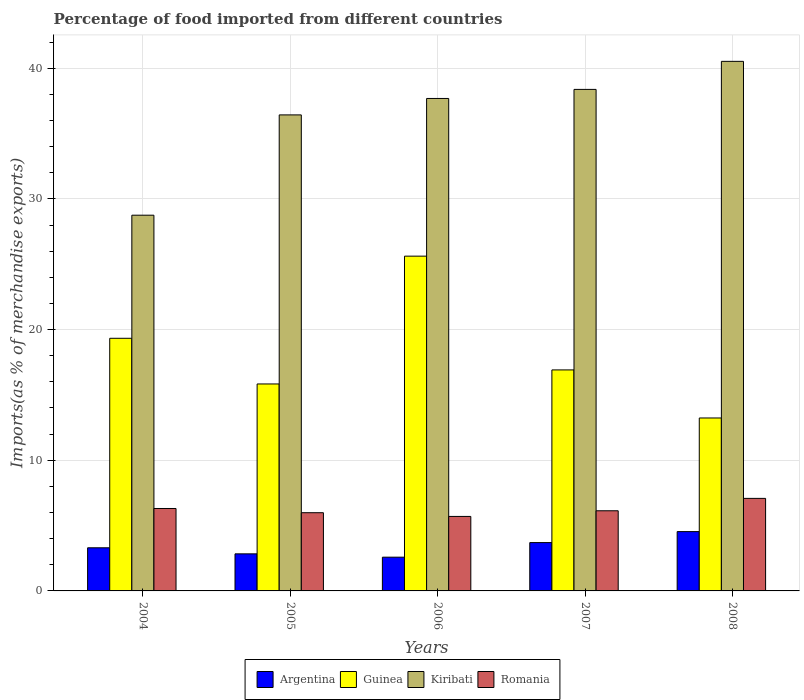How many bars are there on the 4th tick from the left?
Give a very brief answer. 4. How many bars are there on the 5th tick from the right?
Your answer should be very brief. 4. In how many cases, is the number of bars for a given year not equal to the number of legend labels?
Provide a succinct answer. 0. What is the percentage of imports to different countries in Romania in 2006?
Your response must be concise. 5.7. Across all years, what is the maximum percentage of imports to different countries in Romania?
Your answer should be very brief. 7.08. Across all years, what is the minimum percentage of imports to different countries in Guinea?
Provide a succinct answer. 13.23. What is the total percentage of imports to different countries in Romania in the graph?
Your answer should be very brief. 31.21. What is the difference between the percentage of imports to different countries in Argentina in 2006 and that in 2007?
Provide a short and direct response. -1.12. What is the difference between the percentage of imports to different countries in Romania in 2006 and the percentage of imports to different countries in Guinea in 2004?
Provide a short and direct response. -13.63. What is the average percentage of imports to different countries in Guinea per year?
Your answer should be very brief. 18.19. In the year 2004, what is the difference between the percentage of imports to different countries in Romania and percentage of imports to different countries in Argentina?
Offer a terse response. 3.01. In how many years, is the percentage of imports to different countries in Argentina greater than 30 %?
Your answer should be very brief. 0. What is the ratio of the percentage of imports to different countries in Argentina in 2004 to that in 2008?
Make the answer very short. 0.73. Is the percentage of imports to different countries in Guinea in 2005 less than that in 2007?
Your answer should be compact. Yes. What is the difference between the highest and the second highest percentage of imports to different countries in Argentina?
Offer a terse response. 0.84. What is the difference between the highest and the lowest percentage of imports to different countries in Argentina?
Your answer should be very brief. 1.96. Is the sum of the percentage of imports to different countries in Argentina in 2006 and 2008 greater than the maximum percentage of imports to different countries in Romania across all years?
Offer a terse response. Yes. Is it the case that in every year, the sum of the percentage of imports to different countries in Guinea and percentage of imports to different countries in Argentina is greater than the sum of percentage of imports to different countries in Romania and percentage of imports to different countries in Kiribati?
Ensure brevity in your answer.  Yes. What does the 3rd bar from the left in 2005 represents?
Make the answer very short. Kiribati. What does the 4th bar from the right in 2005 represents?
Keep it short and to the point. Argentina. Is it the case that in every year, the sum of the percentage of imports to different countries in Kiribati and percentage of imports to different countries in Guinea is greater than the percentage of imports to different countries in Romania?
Provide a short and direct response. Yes. Are all the bars in the graph horizontal?
Keep it short and to the point. No. Are the values on the major ticks of Y-axis written in scientific E-notation?
Your response must be concise. No. Where does the legend appear in the graph?
Offer a very short reply. Bottom center. How many legend labels are there?
Your answer should be compact. 4. How are the legend labels stacked?
Offer a terse response. Horizontal. What is the title of the graph?
Offer a very short reply. Percentage of food imported from different countries. What is the label or title of the X-axis?
Ensure brevity in your answer.  Years. What is the label or title of the Y-axis?
Your answer should be compact. Imports(as % of merchandise exports). What is the Imports(as % of merchandise exports) of Argentina in 2004?
Offer a very short reply. 3.3. What is the Imports(as % of merchandise exports) in Guinea in 2004?
Your answer should be compact. 19.33. What is the Imports(as % of merchandise exports) in Kiribati in 2004?
Keep it short and to the point. 28.75. What is the Imports(as % of merchandise exports) in Romania in 2004?
Provide a short and direct response. 6.31. What is the Imports(as % of merchandise exports) in Argentina in 2005?
Offer a very short reply. 2.84. What is the Imports(as % of merchandise exports) of Guinea in 2005?
Ensure brevity in your answer.  15.84. What is the Imports(as % of merchandise exports) in Kiribati in 2005?
Give a very brief answer. 36.43. What is the Imports(as % of merchandise exports) of Romania in 2005?
Your response must be concise. 5.98. What is the Imports(as % of merchandise exports) in Argentina in 2006?
Your response must be concise. 2.58. What is the Imports(as % of merchandise exports) in Guinea in 2006?
Give a very brief answer. 25.62. What is the Imports(as % of merchandise exports) in Kiribati in 2006?
Your answer should be compact. 37.69. What is the Imports(as % of merchandise exports) of Romania in 2006?
Ensure brevity in your answer.  5.7. What is the Imports(as % of merchandise exports) in Argentina in 2007?
Your answer should be very brief. 3.7. What is the Imports(as % of merchandise exports) in Guinea in 2007?
Make the answer very short. 16.91. What is the Imports(as % of merchandise exports) in Kiribati in 2007?
Keep it short and to the point. 38.38. What is the Imports(as % of merchandise exports) of Romania in 2007?
Provide a succinct answer. 6.13. What is the Imports(as % of merchandise exports) of Argentina in 2008?
Keep it short and to the point. 4.54. What is the Imports(as % of merchandise exports) of Guinea in 2008?
Keep it short and to the point. 13.23. What is the Imports(as % of merchandise exports) in Kiribati in 2008?
Make the answer very short. 40.52. What is the Imports(as % of merchandise exports) in Romania in 2008?
Ensure brevity in your answer.  7.08. Across all years, what is the maximum Imports(as % of merchandise exports) of Argentina?
Give a very brief answer. 4.54. Across all years, what is the maximum Imports(as % of merchandise exports) in Guinea?
Provide a succinct answer. 25.62. Across all years, what is the maximum Imports(as % of merchandise exports) of Kiribati?
Offer a very short reply. 40.52. Across all years, what is the maximum Imports(as % of merchandise exports) in Romania?
Your answer should be very brief. 7.08. Across all years, what is the minimum Imports(as % of merchandise exports) in Argentina?
Offer a terse response. 2.58. Across all years, what is the minimum Imports(as % of merchandise exports) in Guinea?
Your answer should be compact. 13.23. Across all years, what is the minimum Imports(as % of merchandise exports) in Kiribati?
Provide a short and direct response. 28.75. Across all years, what is the minimum Imports(as % of merchandise exports) in Romania?
Your response must be concise. 5.7. What is the total Imports(as % of merchandise exports) in Argentina in the graph?
Provide a succinct answer. 16.96. What is the total Imports(as % of merchandise exports) in Guinea in the graph?
Offer a terse response. 90.93. What is the total Imports(as % of merchandise exports) of Kiribati in the graph?
Your answer should be very brief. 181.77. What is the total Imports(as % of merchandise exports) in Romania in the graph?
Your answer should be very brief. 31.21. What is the difference between the Imports(as % of merchandise exports) of Argentina in 2004 and that in 2005?
Provide a succinct answer. 0.46. What is the difference between the Imports(as % of merchandise exports) of Guinea in 2004 and that in 2005?
Your answer should be compact. 3.49. What is the difference between the Imports(as % of merchandise exports) of Kiribati in 2004 and that in 2005?
Keep it short and to the point. -7.68. What is the difference between the Imports(as % of merchandise exports) in Romania in 2004 and that in 2005?
Your response must be concise. 0.32. What is the difference between the Imports(as % of merchandise exports) in Argentina in 2004 and that in 2006?
Your response must be concise. 0.72. What is the difference between the Imports(as % of merchandise exports) of Guinea in 2004 and that in 2006?
Make the answer very short. -6.29. What is the difference between the Imports(as % of merchandise exports) in Kiribati in 2004 and that in 2006?
Keep it short and to the point. -8.93. What is the difference between the Imports(as % of merchandise exports) in Romania in 2004 and that in 2006?
Keep it short and to the point. 0.61. What is the difference between the Imports(as % of merchandise exports) in Argentina in 2004 and that in 2007?
Make the answer very short. -0.4. What is the difference between the Imports(as % of merchandise exports) in Guinea in 2004 and that in 2007?
Your answer should be compact. 2.42. What is the difference between the Imports(as % of merchandise exports) in Kiribati in 2004 and that in 2007?
Your answer should be compact. -9.63. What is the difference between the Imports(as % of merchandise exports) in Romania in 2004 and that in 2007?
Provide a succinct answer. 0.18. What is the difference between the Imports(as % of merchandise exports) in Argentina in 2004 and that in 2008?
Your answer should be compact. -1.24. What is the difference between the Imports(as % of merchandise exports) in Guinea in 2004 and that in 2008?
Your response must be concise. 6.1. What is the difference between the Imports(as % of merchandise exports) of Kiribati in 2004 and that in 2008?
Your answer should be compact. -11.77. What is the difference between the Imports(as % of merchandise exports) of Romania in 2004 and that in 2008?
Provide a short and direct response. -0.77. What is the difference between the Imports(as % of merchandise exports) in Argentina in 2005 and that in 2006?
Offer a very short reply. 0.25. What is the difference between the Imports(as % of merchandise exports) in Guinea in 2005 and that in 2006?
Keep it short and to the point. -9.78. What is the difference between the Imports(as % of merchandise exports) in Kiribati in 2005 and that in 2006?
Your answer should be very brief. -1.26. What is the difference between the Imports(as % of merchandise exports) in Romania in 2005 and that in 2006?
Offer a very short reply. 0.28. What is the difference between the Imports(as % of merchandise exports) in Argentina in 2005 and that in 2007?
Give a very brief answer. -0.86. What is the difference between the Imports(as % of merchandise exports) of Guinea in 2005 and that in 2007?
Keep it short and to the point. -1.07. What is the difference between the Imports(as % of merchandise exports) of Kiribati in 2005 and that in 2007?
Your answer should be compact. -1.95. What is the difference between the Imports(as % of merchandise exports) of Romania in 2005 and that in 2007?
Your response must be concise. -0.15. What is the difference between the Imports(as % of merchandise exports) of Argentina in 2005 and that in 2008?
Your answer should be very brief. -1.7. What is the difference between the Imports(as % of merchandise exports) of Guinea in 2005 and that in 2008?
Offer a terse response. 2.6. What is the difference between the Imports(as % of merchandise exports) of Kiribati in 2005 and that in 2008?
Offer a terse response. -4.1. What is the difference between the Imports(as % of merchandise exports) of Romania in 2005 and that in 2008?
Keep it short and to the point. -1.1. What is the difference between the Imports(as % of merchandise exports) of Argentina in 2006 and that in 2007?
Make the answer very short. -1.12. What is the difference between the Imports(as % of merchandise exports) in Guinea in 2006 and that in 2007?
Offer a terse response. 8.71. What is the difference between the Imports(as % of merchandise exports) of Kiribati in 2006 and that in 2007?
Provide a short and direct response. -0.69. What is the difference between the Imports(as % of merchandise exports) of Romania in 2006 and that in 2007?
Your response must be concise. -0.43. What is the difference between the Imports(as % of merchandise exports) of Argentina in 2006 and that in 2008?
Provide a succinct answer. -1.96. What is the difference between the Imports(as % of merchandise exports) in Guinea in 2006 and that in 2008?
Keep it short and to the point. 12.38. What is the difference between the Imports(as % of merchandise exports) of Kiribati in 2006 and that in 2008?
Provide a succinct answer. -2.84. What is the difference between the Imports(as % of merchandise exports) in Romania in 2006 and that in 2008?
Your response must be concise. -1.38. What is the difference between the Imports(as % of merchandise exports) of Argentina in 2007 and that in 2008?
Ensure brevity in your answer.  -0.84. What is the difference between the Imports(as % of merchandise exports) of Guinea in 2007 and that in 2008?
Offer a terse response. 3.68. What is the difference between the Imports(as % of merchandise exports) in Kiribati in 2007 and that in 2008?
Your answer should be very brief. -2.15. What is the difference between the Imports(as % of merchandise exports) of Romania in 2007 and that in 2008?
Give a very brief answer. -0.95. What is the difference between the Imports(as % of merchandise exports) in Argentina in 2004 and the Imports(as % of merchandise exports) in Guinea in 2005?
Make the answer very short. -12.54. What is the difference between the Imports(as % of merchandise exports) of Argentina in 2004 and the Imports(as % of merchandise exports) of Kiribati in 2005?
Keep it short and to the point. -33.13. What is the difference between the Imports(as % of merchandise exports) in Argentina in 2004 and the Imports(as % of merchandise exports) in Romania in 2005?
Make the answer very short. -2.68. What is the difference between the Imports(as % of merchandise exports) of Guinea in 2004 and the Imports(as % of merchandise exports) of Kiribati in 2005?
Provide a short and direct response. -17.09. What is the difference between the Imports(as % of merchandise exports) of Guinea in 2004 and the Imports(as % of merchandise exports) of Romania in 2005?
Provide a short and direct response. 13.35. What is the difference between the Imports(as % of merchandise exports) in Kiribati in 2004 and the Imports(as % of merchandise exports) in Romania in 2005?
Offer a terse response. 22.77. What is the difference between the Imports(as % of merchandise exports) in Argentina in 2004 and the Imports(as % of merchandise exports) in Guinea in 2006?
Provide a succinct answer. -22.32. What is the difference between the Imports(as % of merchandise exports) of Argentina in 2004 and the Imports(as % of merchandise exports) of Kiribati in 2006?
Provide a short and direct response. -34.38. What is the difference between the Imports(as % of merchandise exports) of Argentina in 2004 and the Imports(as % of merchandise exports) of Romania in 2006?
Offer a terse response. -2.4. What is the difference between the Imports(as % of merchandise exports) of Guinea in 2004 and the Imports(as % of merchandise exports) of Kiribati in 2006?
Provide a short and direct response. -18.35. What is the difference between the Imports(as % of merchandise exports) of Guinea in 2004 and the Imports(as % of merchandise exports) of Romania in 2006?
Provide a short and direct response. 13.63. What is the difference between the Imports(as % of merchandise exports) in Kiribati in 2004 and the Imports(as % of merchandise exports) in Romania in 2006?
Keep it short and to the point. 23.05. What is the difference between the Imports(as % of merchandise exports) in Argentina in 2004 and the Imports(as % of merchandise exports) in Guinea in 2007?
Offer a very short reply. -13.61. What is the difference between the Imports(as % of merchandise exports) of Argentina in 2004 and the Imports(as % of merchandise exports) of Kiribati in 2007?
Give a very brief answer. -35.08. What is the difference between the Imports(as % of merchandise exports) in Argentina in 2004 and the Imports(as % of merchandise exports) in Romania in 2007?
Offer a very short reply. -2.83. What is the difference between the Imports(as % of merchandise exports) in Guinea in 2004 and the Imports(as % of merchandise exports) in Kiribati in 2007?
Offer a very short reply. -19.05. What is the difference between the Imports(as % of merchandise exports) of Guinea in 2004 and the Imports(as % of merchandise exports) of Romania in 2007?
Offer a very short reply. 13.2. What is the difference between the Imports(as % of merchandise exports) of Kiribati in 2004 and the Imports(as % of merchandise exports) of Romania in 2007?
Provide a succinct answer. 22.62. What is the difference between the Imports(as % of merchandise exports) in Argentina in 2004 and the Imports(as % of merchandise exports) in Guinea in 2008?
Make the answer very short. -9.93. What is the difference between the Imports(as % of merchandise exports) of Argentina in 2004 and the Imports(as % of merchandise exports) of Kiribati in 2008?
Provide a succinct answer. -37.22. What is the difference between the Imports(as % of merchandise exports) in Argentina in 2004 and the Imports(as % of merchandise exports) in Romania in 2008?
Keep it short and to the point. -3.78. What is the difference between the Imports(as % of merchandise exports) in Guinea in 2004 and the Imports(as % of merchandise exports) in Kiribati in 2008?
Offer a terse response. -21.19. What is the difference between the Imports(as % of merchandise exports) of Guinea in 2004 and the Imports(as % of merchandise exports) of Romania in 2008?
Offer a terse response. 12.25. What is the difference between the Imports(as % of merchandise exports) in Kiribati in 2004 and the Imports(as % of merchandise exports) in Romania in 2008?
Offer a very short reply. 21.67. What is the difference between the Imports(as % of merchandise exports) in Argentina in 2005 and the Imports(as % of merchandise exports) in Guinea in 2006?
Ensure brevity in your answer.  -22.78. What is the difference between the Imports(as % of merchandise exports) in Argentina in 2005 and the Imports(as % of merchandise exports) in Kiribati in 2006?
Provide a short and direct response. -34.85. What is the difference between the Imports(as % of merchandise exports) in Argentina in 2005 and the Imports(as % of merchandise exports) in Romania in 2006?
Offer a terse response. -2.86. What is the difference between the Imports(as % of merchandise exports) in Guinea in 2005 and the Imports(as % of merchandise exports) in Kiribati in 2006?
Provide a short and direct response. -21.85. What is the difference between the Imports(as % of merchandise exports) in Guinea in 2005 and the Imports(as % of merchandise exports) in Romania in 2006?
Your response must be concise. 10.14. What is the difference between the Imports(as % of merchandise exports) of Kiribati in 2005 and the Imports(as % of merchandise exports) of Romania in 2006?
Keep it short and to the point. 30.73. What is the difference between the Imports(as % of merchandise exports) of Argentina in 2005 and the Imports(as % of merchandise exports) of Guinea in 2007?
Give a very brief answer. -14.07. What is the difference between the Imports(as % of merchandise exports) of Argentina in 2005 and the Imports(as % of merchandise exports) of Kiribati in 2007?
Your response must be concise. -35.54. What is the difference between the Imports(as % of merchandise exports) in Argentina in 2005 and the Imports(as % of merchandise exports) in Romania in 2007?
Make the answer very short. -3.3. What is the difference between the Imports(as % of merchandise exports) of Guinea in 2005 and the Imports(as % of merchandise exports) of Kiribati in 2007?
Offer a terse response. -22.54. What is the difference between the Imports(as % of merchandise exports) of Guinea in 2005 and the Imports(as % of merchandise exports) of Romania in 2007?
Keep it short and to the point. 9.7. What is the difference between the Imports(as % of merchandise exports) of Kiribati in 2005 and the Imports(as % of merchandise exports) of Romania in 2007?
Your answer should be compact. 30.29. What is the difference between the Imports(as % of merchandise exports) of Argentina in 2005 and the Imports(as % of merchandise exports) of Guinea in 2008?
Provide a succinct answer. -10.4. What is the difference between the Imports(as % of merchandise exports) of Argentina in 2005 and the Imports(as % of merchandise exports) of Kiribati in 2008?
Provide a succinct answer. -37.69. What is the difference between the Imports(as % of merchandise exports) of Argentina in 2005 and the Imports(as % of merchandise exports) of Romania in 2008?
Provide a succinct answer. -4.24. What is the difference between the Imports(as % of merchandise exports) of Guinea in 2005 and the Imports(as % of merchandise exports) of Kiribati in 2008?
Make the answer very short. -24.69. What is the difference between the Imports(as % of merchandise exports) in Guinea in 2005 and the Imports(as % of merchandise exports) in Romania in 2008?
Offer a very short reply. 8.76. What is the difference between the Imports(as % of merchandise exports) of Kiribati in 2005 and the Imports(as % of merchandise exports) of Romania in 2008?
Keep it short and to the point. 29.35. What is the difference between the Imports(as % of merchandise exports) in Argentina in 2006 and the Imports(as % of merchandise exports) in Guinea in 2007?
Ensure brevity in your answer.  -14.33. What is the difference between the Imports(as % of merchandise exports) in Argentina in 2006 and the Imports(as % of merchandise exports) in Kiribati in 2007?
Make the answer very short. -35.8. What is the difference between the Imports(as % of merchandise exports) in Argentina in 2006 and the Imports(as % of merchandise exports) in Romania in 2007?
Offer a terse response. -3.55. What is the difference between the Imports(as % of merchandise exports) of Guinea in 2006 and the Imports(as % of merchandise exports) of Kiribati in 2007?
Provide a short and direct response. -12.76. What is the difference between the Imports(as % of merchandise exports) of Guinea in 2006 and the Imports(as % of merchandise exports) of Romania in 2007?
Ensure brevity in your answer.  19.49. What is the difference between the Imports(as % of merchandise exports) of Kiribati in 2006 and the Imports(as % of merchandise exports) of Romania in 2007?
Offer a terse response. 31.55. What is the difference between the Imports(as % of merchandise exports) of Argentina in 2006 and the Imports(as % of merchandise exports) of Guinea in 2008?
Offer a terse response. -10.65. What is the difference between the Imports(as % of merchandise exports) of Argentina in 2006 and the Imports(as % of merchandise exports) of Kiribati in 2008?
Keep it short and to the point. -37.94. What is the difference between the Imports(as % of merchandise exports) of Argentina in 2006 and the Imports(as % of merchandise exports) of Romania in 2008?
Provide a short and direct response. -4.5. What is the difference between the Imports(as % of merchandise exports) of Guinea in 2006 and the Imports(as % of merchandise exports) of Kiribati in 2008?
Make the answer very short. -14.91. What is the difference between the Imports(as % of merchandise exports) in Guinea in 2006 and the Imports(as % of merchandise exports) in Romania in 2008?
Your answer should be very brief. 18.54. What is the difference between the Imports(as % of merchandise exports) in Kiribati in 2006 and the Imports(as % of merchandise exports) in Romania in 2008?
Offer a very short reply. 30.6. What is the difference between the Imports(as % of merchandise exports) of Argentina in 2007 and the Imports(as % of merchandise exports) of Guinea in 2008?
Your response must be concise. -9.54. What is the difference between the Imports(as % of merchandise exports) of Argentina in 2007 and the Imports(as % of merchandise exports) of Kiribati in 2008?
Provide a short and direct response. -36.83. What is the difference between the Imports(as % of merchandise exports) in Argentina in 2007 and the Imports(as % of merchandise exports) in Romania in 2008?
Your response must be concise. -3.38. What is the difference between the Imports(as % of merchandise exports) in Guinea in 2007 and the Imports(as % of merchandise exports) in Kiribati in 2008?
Your response must be concise. -23.61. What is the difference between the Imports(as % of merchandise exports) of Guinea in 2007 and the Imports(as % of merchandise exports) of Romania in 2008?
Make the answer very short. 9.83. What is the difference between the Imports(as % of merchandise exports) of Kiribati in 2007 and the Imports(as % of merchandise exports) of Romania in 2008?
Your answer should be very brief. 31.3. What is the average Imports(as % of merchandise exports) of Argentina per year?
Ensure brevity in your answer.  3.39. What is the average Imports(as % of merchandise exports) in Guinea per year?
Give a very brief answer. 18.19. What is the average Imports(as % of merchandise exports) in Kiribati per year?
Offer a terse response. 36.35. What is the average Imports(as % of merchandise exports) in Romania per year?
Offer a terse response. 6.24. In the year 2004, what is the difference between the Imports(as % of merchandise exports) in Argentina and Imports(as % of merchandise exports) in Guinea?
Make the answer very short. -16.03. In the year 2004, what is the difference between the Imports(as % of merchandise exports) in Argentina and Imports(as % of merchandise exports) in Kiribati?
Your response must be concise. -25.45. In the year 2004, what is the difference between the Imports(as % of merchandise exports) in Argentina and Imports(as % of merchandise exports) in Romania?
Your answer should be very brief. -3.01. In the year 2004, what is the difference between the Imports(as % of merchandise exports) in Guinea and Imports(as % of merchandise exports) in Kiribati?
Your response must be concise. -9.42. In the year 2004, what is the difference between the Imports(as % of merchandise exports) of Guinea and Imports(as % of merchandise exports) of Romania?
Provide a succinct answer. 13.02. In the year 2004, what is the difference between the Imports(as % of merchandise exports) of Kiribati and Imports(as % of merchandise exports) of Romania?
Your response must be concise. 22.44. In the year 2005, what is the difference between the Imports(as % of merchandise exports) in Argentina and Imports(as % of merchandise exports) in Guinea?
Keep it short and to the point. -13. In the year 2005, what is the difference between the Imports(as % of merchandise exports) of Argentina and Imports(as % of merchandise exports) of Kiribati?
Provide a short and direct response. -33.59. In the year 2005, what is the difference between the Imports(as % of merchandise exports) of Argentina and Imports(as % of merchandise exports) of Romania?
Make the answer very short. -3.15. In the year 2005, what is the difference between the Imports(as % of merchandise exports) in Guinea and Imports(as % of merchandise exports) in Kiribati?
Your response must be concise. -20.59. In the year 2005, what is the difference between the Imports(as % of merchandise exports) in Guinea and Imports(as % of merchandise exports) in Romania?
Offer a terse response. 9.85. In the year 2005, what is the difference between the Imports(as % of merchandise exports) in Kiribati and Imports(as % of merchandise exports) in Romania?
Your response must be concise. 30.44. In the year 2006, what is the difference between the Imports(as % of merchandise exports) of Argentina and Imports(as % of merchandise exports) of Guinea?
Provide a succinct answer. -23.04. In the year 2006, what is the difference between the Imports(as % of merchandise exports) of Argentina and Imports(as % of merchandise exports) of Kiribati?
Offer a very short reply. -35.1. In the year 2006, what is the difference between the Imports(as % of merchandise exports) of Argentina and Imports(as % of merchandise exports) of Romania?
Your answer should be very brief. -3.12. In the year 2006, what is the difference between the Imports(as % of merchandise exports) in Guinea and Imports(as % of merchandise exports) in Kiribati?
Make the answer very short. -12.07. In the year 2006, what is the difference between the Imports(as % of merchandise exports) of Guinea and Imports(as % of merchandise exports) of Romania?
Provide a succinct answer. 19.92. In the year 2006, what is the difference between the Imports(as % of merchandise exports) of Kiribati and Imports(as % of merchandise exports) of Romania?
Ensure brevity in your answer.  31.98. In the year 2007, what is the difference between the Imports(as % of merchandise exports) of Argentina and Imports(as % of merchandise exports) of Guinea?
Your response must be concise. -13.21. In the year 2007, what is the difference between the Imports(as % of merchandise exports) in Argentina and Imports(as % of merchandise exports) in Kiribati?
Offer a terse response. -34.68. In the year 2007, what is the difference between the Imports(as % of merchandise exports) of Argentina and Imports(as % of merchandise exports) of Romania?
Offer a very short reply. -2.43. In the year 2007, what is the difference between the Imports(as % of merchandise exports) of Guinea and Imports(as % of merchandise exports) of Kiribati?
Offer a terse response. -21.47. In the year 2007, what is the difference between the Imports(as % of merchandise exports) in Guinea and Imports(as % of merchandise exports) in Romania?
Keep it short and to the point. 10.78. In the year 2007, what is the difference between the Imports(as % of merchandise exports) of Kiribati and Imports(as % of merchandise exports) of Romania?
Make the answer very short. 32.25. In the year 2008, what is the difference between the Imports(as % of merchandise exports) in Argentina and Imports(as % of merchandise exports) in Guinea?
Provide a short and direct response. -8.7. In the year 2008, what is the difference between the Imports(as % of merchandise exports) of Argentina and Imports(as % of merchandise exports) of Kiribati?
Provide a succinct answer. -35.99. In the year 2008, what is the difference between the Imports(as % of merchandise exports) in Argentina and Imports(as % of merchandise exports) in Romania?
Your answer should be compact. -2.54. In the year 2008, what is the difference between the Imports(as % of merchandise exports) in Guinea and Imports(as % of merchandise exports) in Kiribati?
Give a very brief answer. -27.29. In the year 2008, what is the difference between the Imports(as % of merchandise exports) in Guinea and Imports(as % of merchandise exports) in Romania?
Keep it short and to the point. 6.15. In the year 2008, what is the difference between the Imports(as % of merchandise exports) of Kiribati and Imports(as % of merchandise exports) of Romania?
Offer a very short reply. 33.44. What is the ratio of the Imports(as % of merchandise exports) in Argentina in 2004 to that in 2005?
Provide a short and direct response. 1.16. What is the ratio of the Imports(as % of merchandise exports) in Guinea in 2004 to that in 2005?
Offer a very short reply. 1.22. What is the ratio of the Imports(as % of merchandise exports) of Kiribati in 2004 to that in 2005?
Your answer should be very brief. 0.79. What is the ratio of the Imports(as % of merchandise exports) of Romania in 2004 to that in 2005?
Offer a terse response. 1.05. What is the ratio of the Imports(as % of merchandise exports) of Argentina in 2004 to that in 2006?
Your answer should be compact. 1.28. What is the ratio of the Imports(as % of merchandise exports) of Guinea in 2004 to that in 2006?
Your answer should be very brief. 0.75. What is the ratio of the Imports(as % of merchandise exports) of Kiribati in 2004 to that in 2006?
Provide a short and direct response. 0.76. What is the ratio of the Imports(as % of merchandise exports) in Romania in 2004 to that in 2006?
Provide a succinct answer. 1.11. What is the ratio of the Imports(as % of merchandise exports) of Argentina in 2004 to that in 2007?
Your response must be concise. 0.89. What is the ratio of the Imports(as % of merchandise exports) in Guinea in 2004 to that in 2007?
Provide a short and direct response. 1.14. What is the ratio of the Imports(as % of merchandise exports) in Kiribati in 2004 to that in 2007?
Your answer should be compact. 0.75. What is the ratio of the Imports(as % of merchandise exports) in Romania in 2004 to that in 2007?
Ensure brevity in your answer.  1.03. What is the ratio of the Imports(as % of merchandise exports) of Argentina in 2004 to that in 2008?
Give a very brief answer. 0.73. What is the ratio of the Imports(as % of merchandise exports) in Guinea in 2004 to that in 2008?
Your answer should be very brief. 1.46. What is the ratio of the Imports(as % of merchandise exports) in Kiribati in 2004 to that in 2008?
Your response must be concise. 0.71. What is the ratio of the Imports(as % of merchandise exports) of Romania in 2004 to that in 2008?
Give a very brief answer. 0.89. What is the ratio of the Imports(as % of merchandise exports) in Argentina in 2005 to that in 2006?
Your answer should be very brief. 1.1. What is the ratio of the Imports(as % of merchandise exports) of Guinea in 2005 to that in 2006?
Your answer should be compact. 0.62. What is the ratio of the Imports(as % of merchandise exports) of Kiribati in 2005 to that in 2006?
Provide a succinct answer. 0.97. What is the ratio of the Imports(as % of merchandise exports) in Romania in 2005 to that in 2006?
Give a very brief answer. 1.05. What is the ratio of the Imports(as % of merchandise exports) in Argentina in 2005 to that in 2007?
Make the answer very short. 0.77. What is the ratio of the Imports(as % of merchandise exports) in Guinea in 2005 to that in 2007?
Your answer should be compact. 0.94. What is the ratio of the Imports(as % of merchandise exports) of Kiribati in 2005 to that in 2007?
Your answer should be very brief. 0.95. What is the ratio of the Imports(as % of merchandise exports) in Romania in 2005 to that in 2007?
Provide a succinct answer. 0.98. What is the ratio of the Imports(as % of merchandise exports) of Guinea in 2005 to that in 2008?
Keep it short and to the point. 1.2. What is the ratio of the Imports(as % of merchandise exports) of Kiribati in 2005 to that in 2008?
Offer a very short reply. 0.9. What is the ratio of the Imports(as % of merchandise exports) in Romania in 2005 to that in 2008?
Ensure brevity in your answer.  0.85. What is the ratio of the Imports(as % of merchandise exports) in Argentina in 2006 to that in 2007?
Your response must be concise. 0.7. What is the ratio of the Imports(as % of merchandise exports) of Guinea in 2006 to that in 2007?
Keep it short and to the point. 1.51. What is the ratio of the Imports(as % of merchandise exports) in Kiribati in 2006 to that in 2007?
Your answer should be compact. 0.98. What is the ratio of the Imports(as % of merchandise exports) in Romania in 2006 to that in 2007?
Your response must be concise. 0.93. What is the ratio of the Imports(as % of merchandise exports) in Argentina in 2006 to that in 2008?
Provide a short and direct response. 0.57. What is the ratio of the Imports(as % of merchandise exports) of Guinea in 2006 to that in 2008?
Offer a terse response. 1.94. What is the ratio of the Imports(as % of merchandise exports) of Kiribati in 2006 to that in 2008?
Offer a terse response. 0.93. What is the ratio of the Imports(as % of merchandise exports) of Romania in 2006 to that in 2008?
Your response must be concise. 0.81. What is the ratio of the Imports(as % of merchandise exports) in Argentina in 2007 to that in 2008?
Provide a short and direct response. 0.81. What is the ratio of the Imports(as % of merchandise exports) of Guinea in 2007 to that in 2008?
Make the answer very short. 1.28. What is the ratio of the Imports(as % of merchandise exports) in Kiribati in 2007 to that in 2008?
Offer a very short reply. 0.95. What is the ratio of the Imports(as % of merchandise exports) of Romania in 2007 to that in 2008?
Make the answer very short. 0.87. What is the difference between the highest and the second highest Imports(as % of merchandise exports) in Argentina?
Offer a terse response. 0.84. What is the difference between the highest and the second highest Imports(as % of merchandise exports) of Guinea?
Ensure brevity in your answer.  6.29. What is the difference between the highest and the second highest Imports(as % of merchandise exports) of Kiribati?
Your answer should be compact. 2.15. What is the difference between the highest and the second highest Imports(as % of merchandise exports) in Romania?
Give a very brief answer. 0.77. What is the difference between the highest and the lowest Imports(as % of merchandise exports) of Argentina?
Your answer should be very brief. 1.96. What is the difference between the highest and the lowest Imports(as % of merchandise exports) in Guinea?
Ensure brevity in your answer.  12.38. What is the difference between the highest and the lowest Imports(as % of merchandise exports) in Kiribati?
Your answer should be very brief. 11.77. What is the difference between the highest and the lowest Imports(as % of merchandise exports) in Romania?
Your response must be concise. 1.38. 